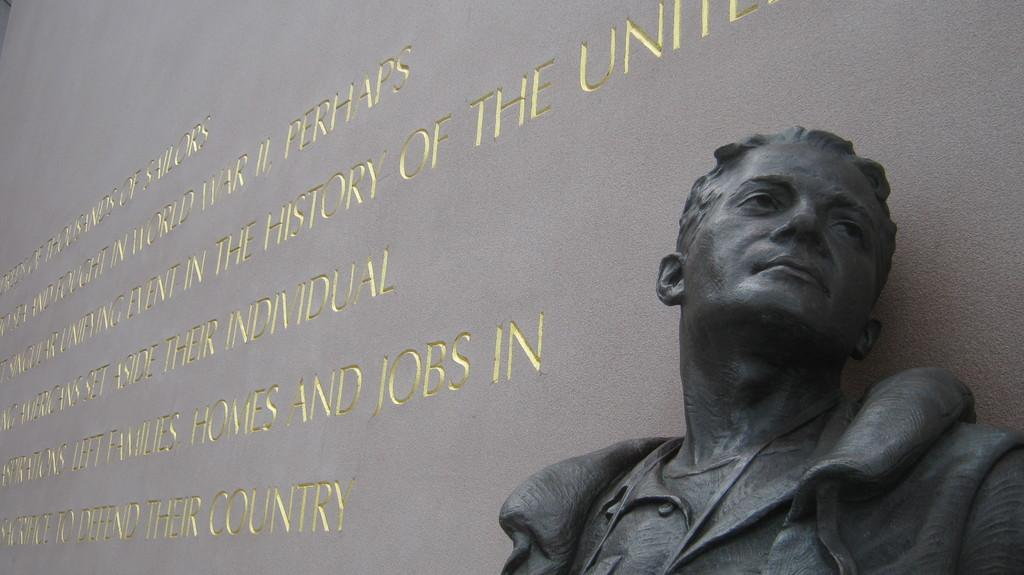What is the main subject of the image? There is a sculpture in the image. Where is the sculpture located in relation to other elements in the image? The sculpture is near a wall. What can be seen on the wall in the image? There is text written on the wall in the image. Is the sculpture sinking in quicksand in the image? No, there is no quicksand present in the image, and the sculpture is not sinking. What type of note is attached to the sculpture in the image? There is no note attached to the sculpture in the image. 